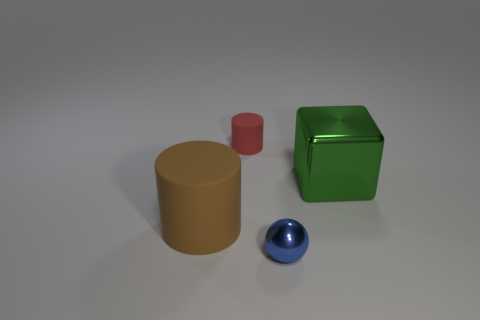There is a green cube; how many small cylinders are on the right side of it? There are two small cylinders, a yellow and a red one, located on the right side of the green cube. 